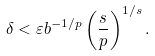Convert formula to latex. <formula><loc_0><loc_0><loc_500><loc_500>\delta < \varepsilon b ^ { - 1 / p } \left ( \frac { s } { p } \right ) ^ { 1 / s } .</formula> 